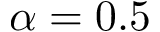<formula> <loc_0><loc_0><loc_500><loc_500>\alpha = 0 . 5</formula> 